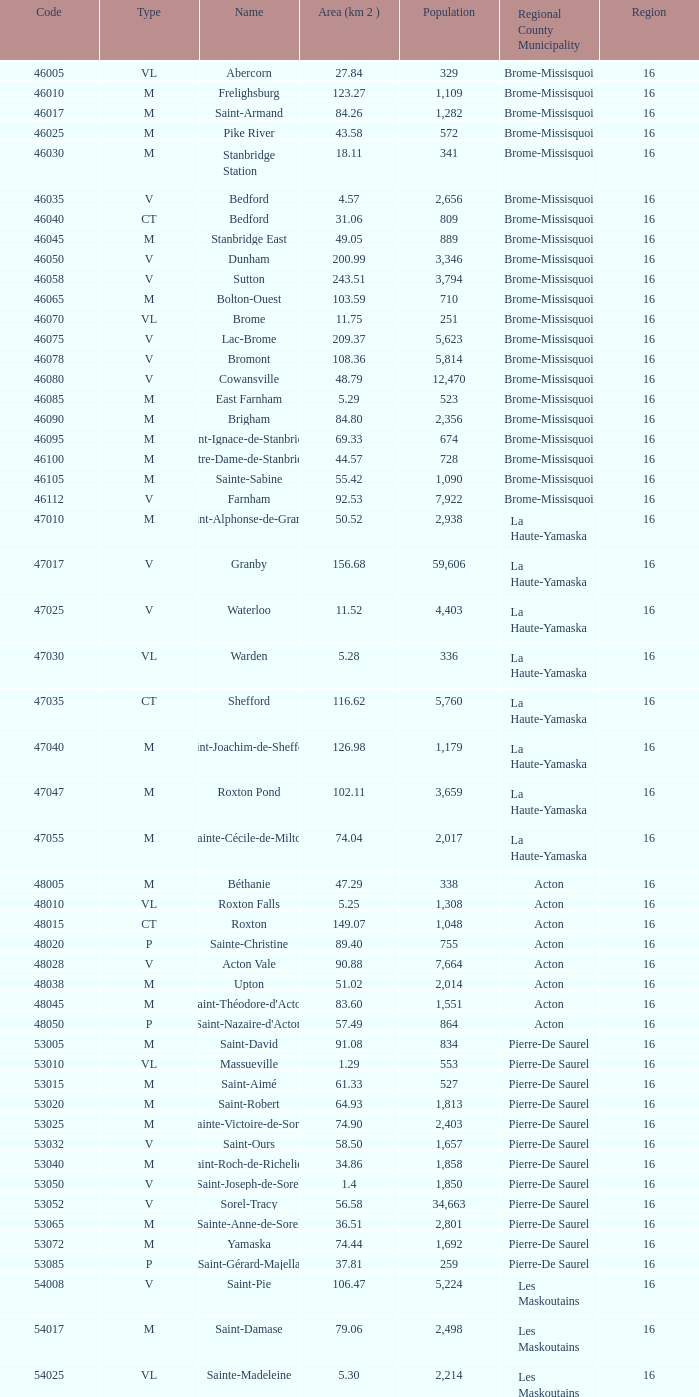Can you provide the code for a le haut-saint-laurent municipality consisting of at least 16 regions? None. 